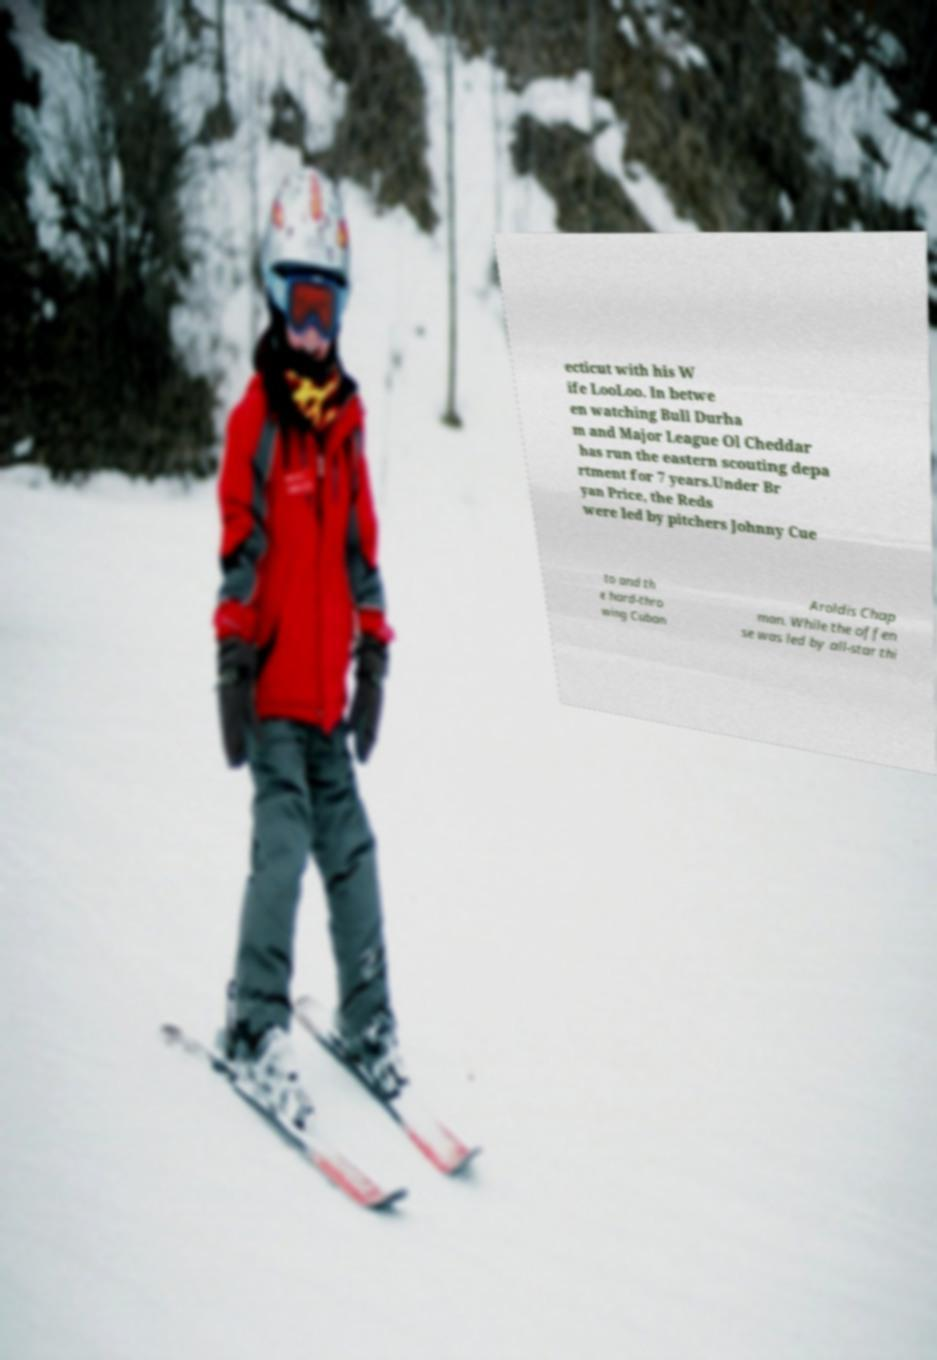Could you assist in decoding the text presented in this image and type it out clearly? ecticut with his W ife LooLoo. In betwe en watching Bull Durha m and Major League Ol Cheddar has run the eastern scouting depa rtment for 7 years.Under Br yan Price, the Reds were led by pitchers Johnny Cue to and th e hard-thro wing Cuban Aroldis Chap man. While the offen se was led by all-star thi 